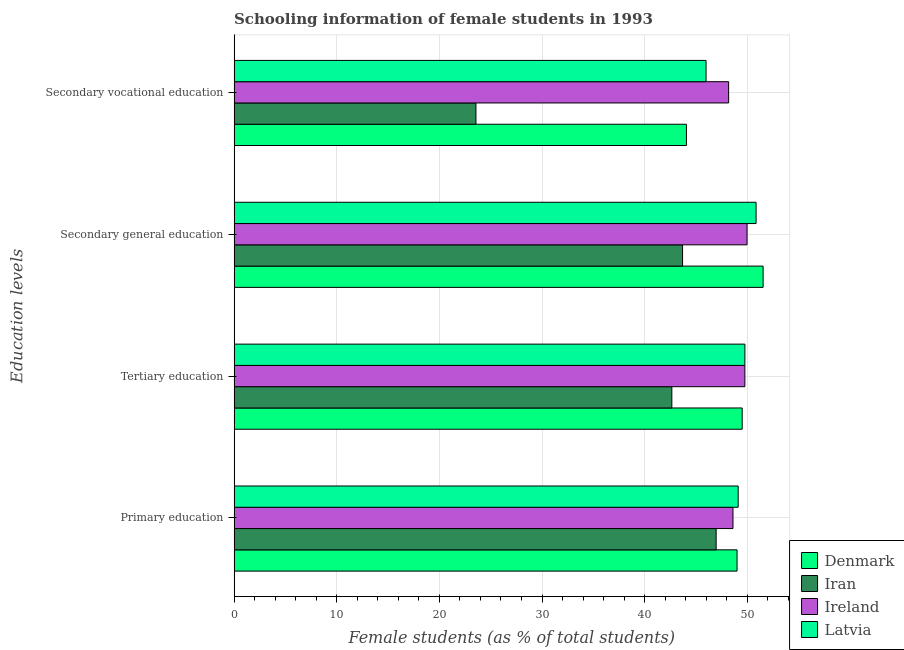How many bars are there on the 2nd tick from the top?
Offer a terse response. 4. How many bars are there on the 1st tick from the bottom?
Provide a succinct answer. 4. What is the label of the 3rd group of bars from the top?
Your answer should be very brief. Tertiary education. What is the percentage of female students in primary education in Ireland?
Provide a succinct answer. 48.6. Across all countries, what is the maximum percentage of female students in primary education?
Your answer should be compact. 49.11. Across all countries, what is the minimum percentage of female students in tertiary education?
Offer a very short reply. 42.65. In which country was the percentage of female students in secondary vocational education maximum?
Make the answer very short. Ireland. In which country was the percentage of female students in secondary vocational education minimum?
Offer a very short reply. Iran. What is the total percentage of female students in tertiary education in the graph?
Provide a succinct answer. 191.67. What is the difference between the percentage of female students in secondary education in Latvia and that in Denmark?
Ensure brevity in your answer.  -0.68. What is the difference between the percentage of female students in tertiary education in Latvia and the percentage of female students in primary education in Denmark?
Provide a short and direct response. 0.76. What is the average percentage of female students in secondary education per country?
Make the answer very short. 49.01. What is the difference between the percentage of female students in primary education and percentage of female students in tertiary education in Ireland?
Your answer should be compact. -1.16. In how many countries, is the percentage of female students in tertiary education greater than 40 %?
Make the answer very short. 4. What is the ratio of the percentage of female students in secondary vocational education in Denmark to that in Ireland?
Keep it short and to the point. 0.91. Is the percentage of female students in tertiary education in Ireland less than that in Latvia?
Your answer should be compact. Yes. What is the difference between the highest and the second highest percentage of female students in secondary vocational education?
Ensure brevity in your answer.  2.2. What is the difference between the highest and the lowest percentage of female students in primary education?
Make the answer very short. 2.15. Is the sum of the percentage of female students in tertiary education in Latvia and Denmark greater than the maximum percentage of female students in secondary education across all countries?
Provide a succinct answer. Yes. Is it the case that in every country, the sum of the percentage of female students in primary education and percentage of female students in tertiary education is greater than the sum of percentage of female students in secondary vocational education and percentage of female students in secondary education?
Offer a terse response. No. What does the 1st bar from the top in Secondary general education represents?
Give a very brief answer. Latvia. What does the 4th bar from the bottom in Secondary general education represents?
Keep it short and to the point. Latvia. Is it the case that in every country, the sum of the percentage of female students in primary education and percentage of female students in tertiary education is greater than the percentage of female students in secondary education?
Give a very brief answer. Yes. Are all the bars in the graph horizontal?
Your answer should be very brief. Yes. How many countries are there in the graph?
Your response must be concise. 4. Does the graph contain any zero values?
Ensure brevity in your answer.  No. Where does the legend appear in the graph?
Your response must be concise. Bottom right. How many legend labels are there?
Keep it short and to the point. 4. What is the title of the graph?
Your response must be concise. Schooling information of female students in 1993. What is the label or title of the X-axis?
Provide a succinct answer. Female students (as % of total students). What is the label or title of the Y-axis?
Your answer should be very brief. Education levels. What is the Female students (as % of total students) of Denmark in Primary education?
Keep it short and to the point. 49. What is the Female students (as % of total students) in Iran in Primary education?
Offer a terse response. 46.96. What is the Female students (as % of total students) in Ireland in Primary education?
Provide a succinct answer. 48.6. What is the Female students (as % of total students) in Latvia in Primary education?
Offer a very short reply. 49.11. What is the Female students (as % of total students) of Denmark in Tertiary education?
Offer a very short reply. 49.5. What is the Female students (as % of total students) in Iran in Tertiary education?
Give a very brief answer. 42.65. What is the Female students (as % of total students) of Ireland in Tertiary education?
Give a very brief answer. 49.76. What is the Female students (as % of total students) of Latvia in Tertiary education?
Provide a short and direct response. 49.76. What is the Female students (as % of total students) in Denmark in Secondary general education?
Offer a terse response. 51.54. What is the Female students (as % of total students) in Iran in Secondary general education?
Your response must be concise. 43.69. What is the Female students (as % of total students) of Ireland in Secondary general education?
Your answer should be compact. 49.97. What is the Female students (as % of total students) of Latvia in Secondary general education?
Keep it short and to the point. 50.86. What is the Female students (as % of total students) in Denmark in Secondary vocational education?
Offer a terse response. 44.07. What is the Female students (as % of total students) of Iran in Secondary vocational education?
Offer a very short reply. 23.56. What is the Female students (as % of total students) of Ireland in Secondary vocational education?
Give a very brief answer. 48.18. What is the Female students (as % of total students) of Latvia in Secondary vocational education?
Your response must be concise. 45.98. Across all Education levels, what is the maximum Female students (as % of total students) in Denmark?
Your response must be concise. 51.54. Across all Education levels, what is the maximum Female students (as % of total students) in Iran?
Your answer should be very brief. 46.96. Across all Education levels, what is the maximum Female students (as % of total students) in Ireland?
Keep it short and to the point. 49.97. Across all Education levels, what is the maximum Female students (as % of total students) of Latvia?
Your answer should be compact. 50.86. Across all Education levels, what is the minimum Female students (as % of total students) of Denmark?
Ensure brevity in your answer.  44.07. Across all Education levels, what is the minimum Female students (as % of total students) of Iran?
Offer a very short reply. 23.56. Across all Education levels, what is the minimum Female students (as % of total students) in Ireland?
Ensure brevity in your answer.  48.18. Across all Education levels, what is the minimum Female students (as % of total students) in Latvia?
Your response must be concise. 45.98. What is the total Female students (as % of total students) in Denmark in the graph?
Your response must be concise. 194.11. What is the total Female students (as % of total students) in Iran in the graph?
Provide a succinct answer. 156.86. What is the total Female students (as % of total students) in Ireland in the graph?
Ensure brevity in your answer.  196.52. What is the total Female students (as % of total students) of Latvia in the graph?
Provide a succinct answer. 195.71. What is the difference between the Female students (as % of total students) of Denmark in Primary education and that in Tertiary education?
Your answer should be very brief. -0.5. What is the difference between the Female students (as % of total students) of Iran in Primary education and that in Tertiary education?
Offer a terse response. 4.32. What is the difference between the Female students (as % of total students) in Ireland in Primary education and that in Tertiary education?
Offer a very short reply. -1.16. What is the difference between the Female students (as % of total students) in Latvia in Primary education and that in Tertiary education?
Your response must be concise. -0.65. What is the difference between the Female students (as % of total students) in Denmark in Primary education and that in Secondary general education?
Provide a short and direct response. -2.54. What is the difference between the Female students (as % of total students) in Iran in Primary education and that in Secondary general education?
Your answer should be compact. 3.27. What is the difference between the Female students (as % of total students) of Ireland in Primary education and that in Secondary general education?
Your response must be concise. -1.37. What is the difference between the Female students (as % of total students) in Latvia in Primary education and that in Secondary general education?
Provide a short and direct response. -1.75. What is the difference between the Female students (as % of total students) of Denmark in Primary education and that in Secondary vocational education?
Make the answer very short. 4.93. What is the difference between the Female students (as % of total students) of Iran in Primary education and that in Secondary vocational education?
Offer a terse response. 23.4. What is the difference between the Female students (as % of total students) in Ireland in Primary education and that in Secondary vocational education?
Keep it short and to the point. 0.43. What is the difference between the Female students (as % of total students) of Latvia in Primary education and that in Secondary vocational education?
Ensure brevity in your answer.  3.13. What is the difference between the Female students (as % of total students) of Denmark in Tertiary education and that in Secondary general education?
Make the answer very short. -2.04. What is the difference between the Female students (as % of total students) of Iran in Tertiary education and that in Secondary general education?
Ensure brevity in your answer.  -1.04. What is the difference between the Female students (as % of total students) of Ireland in Tertiary education and that in Secondary general education?
Keep it short and to the point. -0.21. What is the difference between the Female students (as % of total students) of Latvia in Tertiary education and that in Secondary general education?
Provide a short and direct response. -1.09. What is the difference between the Female students (as % of total students) of Denmark in Tertiary education and that in Secondary vocational education?
Offer a very short reply. 5.43. What is the difference between the Female students (as % of total students) in Iran in Tertiary education and that in Secondary vocational education?
Ensure brevity in your answer.  19.09. What is the difference between the Female students (as % of total students) of Ireland in Tertiary education and that in Secondary vocational education?
Ensure brevity in your answer.  1.58. What is the difference between the Female students (as % of total students) in Latvia in Tertiary education and that in Secondary vocational education?
Give a very brief answer. 3.78. What is the difference between the Female students (as % of total students) in Denmark in Secondary general education and that in Secondary vocational education?
Offer a terse response. 7.47. What is the difference between the Female students (as % of total students) in Iran in Secondary general education and that in Secondary vocational education?
Make the answer very short. 20.13. What is the difference between the Female students (as % of total students) of Ireland in Secondary general education and that in Secondary vocational education?
Keep it short and to the point. 1.79. What is the difference between the Female students (as % of total students) in Latvia in Secondary general education and that in Secondary vocational education?
Make the answer very short. 4.87. What is the difference between the Female students (as % of total students) of Denmark in Primary education and the Female students (as % of total students) of Iran in Tertiary education?
Make the answer very short. 6.35. What is the difference between the Female students (as % of total students) of Denmark in Primary education and the Female students (as % of total students) of Ireland in Tertiary education?
Your answer should be very brief. -0.76. What is the difference between the Female students (as % of total students) in Denmark in Primary education and the Female students (as % of total students) in Latvia in Tertiary education?
Make the answer very short. -0.76. What is the difference between the Female students (as % of total students) in Iran in Primary education and the Female students (as % of total students) in Ireland in Tertiary education?
Your answer should be very brief. -2.8. What is the difference between the Female students (as % of total students) of Iran in Primary education and the Female students (as % of total students) of Latvia in Tertiary education?
Provide a succinct answer. -2.8. What is the difference between the Female students (as % of total students) in Ireland in Primary education and the Female students (as % of total students) in Latvia in Tertiary education?
Give a very brief answer. -1.16. What is the difference between the Female students (as % of total students) of Denmark in Primary education and the Female students (as % of total students) of Iran in Secondary general education?
Provide a succinct answer. 5.31. What is the difference between the Female students (as % of total students) of Denmark in Primary education and the Female students (as % of total students) of Ireland in Secondary general education?
Offer a terse response. -0.97. What is the difference between the Female students (as % of total students) in Denmark in Primary education and the Female students (as % of total students) in Latvia in Secondary general education?
Offer a very short reply. -1.85. What is the difference between the Female students (as % of total students) of Iran in Primary education and the Female students (as % of total students) of Ireland in Secondary general education?
Your answer should be compact. -3.01. What is the difference between the Female students (as % of total students) in Iran in Primary education and the Female students (as % of total students) in Latvia in Secondary general education?
Provide a short and direct response. -3.89. What is the difference between the Female students (as % of total students) of Ireland in Primary education and the Female students (as % of total students) of Latvia in Secondary general education?
Give a very brief answer. -2.25. What is the difference between the Female students (as % of total students) of Denmark in Primary education and the Female students (as % of total students) of Iran in Secondary vocational education?
Your response must be concise. 25.44. What is the difference between the Female students (as % of total students) in Denmark in Primary education and the Female students (as % of total students) in Ireland in Secondary vocational education?
Offer a terse response. 0.82. What is the difference between the Female students (as % of total students) of Denmark in Primary education and the Female students (as % of total students) of Latvia in Secondary vocational education?
Ensure brevity in your answer.  3.02. What is the difference between the Female students (as % of total students) of Iran in Primary education and the Female students (as % of total students) of Ireland in Secondary vocational education?
Provide a succinct answer. -1.22. What is the difference between the Female students (as % of total students) of Iran in Primary education and the Female students (as % of total students) of Latvia in Secondary vocational education?
Ensure brevity in your answer.  0.98. What is the difference between the Female students (as % of total students) of Ireland in Primary education and the Female students (as % of total students) of Latvia in Secondary vocational education?
Your answer should be compact. 2.62. What is the difference between the Female students (as % of total students) of Denmark in Tertiary education and the Female students (as % of total students) of Iran in Secondary general education?
Make the answer very short. 5.81. What is the difference between the Female students (as % of total students) of Denmark in Tertiary education and the Female students (as % of total students) of Ireland in Secondary general education?
Your answer should be compact. -0.47. What is the difference between the Female students (as % of total students) of Denmark in Tertiary education and the Female students (as % of total students) of Latvia in Secondary general education?
Provide a short and direct response. -1.36. What is the difference between the Female students (as % of total students) of Iran in Tertiary education and the Female students (as % of total students) of Ireland in Secondary general education?
Your answer should be very brief. -7.33. What is the difference between the Female students (as % of total students) in Iran in Tertiary education and the Female students (as % of total students) in Latvia in Secondary general education?
Your answer should be very brief. -8.21. What is the difference between the Female students (as % of total students) in Ireland in Tertiary education and the Female students (as % of total students) in Latvia in Secondary general education?
Your response must be concise. -1.09. What is the difference between the Female students (as % of total students) of Denmark in Tertiary education and the Female students (as % of total students) of Iran in Secondary vocational education?
Keep it short and to the point. 25.94. What is the difference between the Female students (as % of total students) of Denmark in Tertiary education and the Female students (as % of total students) of Ireland in Secondary vocational education?
Keep it short and to the point. 1.32. What is the difference between the Female students (as % of total students) of Denmark in Tertiary education and the Female students (as % of total students) of Latvia in Secondary vocational education?
Your response must be concise. 3.52. What is the difference between the Female students (as % of total students) in Iran in Tertiary education and the Female students (as % of total students) in Ireland in Secondary vocational education?
Provide a short and direct response. -5.53. What is the difference between the Female students (as % of total students) of Iran in Tertiary education and the Female students (as % of total students) of Latvia in Secondary vocational education?
Provide a short and direct response. -3.33. What is the difference between the Female students (as % of total students) in Ireland in Tertiary education and the Female students (as % of total students) in Latvia in Secondary vocational education?
Ensure brevity in your answer.  3.78. What is the difference between the Female students (as % of total students) of Denmark in Secondary general education and the Female students (as % of total students) of Iran in Secondary vocational education?
Your answer should be very brief. 27.98. What is the difference between the Female students (as % of total students) in Denmark in Secondary general education and the Female students (as % of total students) in Ireland in Secondary vocational education?
Ensure brevity in your answer.  3.36. What is the difference between the Female students (as % of total students) of Denmark in Secondary general education and the Female students (as % of total students) of Latvia in Secondary vocational education?
Your answer should be compact. 5.56. What is the difference between the Female students (as % of total students) of Iran in Secondary general education and the Female students (as % of total students) of Ireland in Secondary vocational education?
Offer a terse response. -4.49. What is the difference between the Female students (as % of total students) in Iran in Secondary general education and the Female students (as % of total students) in Latvia in Secondary vocational education?
Offer a terse response. -2.29. What is the difference between the Female students (as % of total students) of Ireland in Secondary general education and the Female students (as % of total students) of Latvia in Secondary vocational education?
Ensure brevity in your answer.  3.99. What is the average Female students (as % of total students) in Denmark per Education levels?
Give a very brief answer. 48.53. What is the average Female students (as % of total students) in Iran per Education levels?
Provide a succinct answer. 39.22. What is the average Female students (as % of total students) in Ireland per Education levels?
Ensure brevity in your answer.  49.13. What is the average Female students (as % of total students) of Latvia per Education levels?
Ensure brevity in your answer.  48.93. What is the difference between the Female students (as % of total students) in Denmark and Female students (as % of total students) in Iran in Primary education?
Your answer should be very brief. 2.04. What is the difference between the Female students (as % of total students) in Denmark and Female students (as % of total students) in Ireland in Primary education?
Make the answer very short. 0.4. What is the difference between the Female students (as % of total students) in Denmark and Female students (as % of total students) in Latvia in Primary education?
Your answer should be compact. -0.11. What is the difference between the Female students (as % of total students) in Iran and Female students (as % of total students) in Ireland in Primary education?
Offer a terse response. -1.64. What is the difference between the Female students (as % of total students) in Iran and Female students (as % of total students) in Latvia in Primary education?
Your answer should be compact. -2.15. What is the difference between the Female students (as % of total students) in Ireland and Female students (as % of total students) in Latvia in Primary education?
Ensure brevity in your answer.  -0.51. What is the difference between the Female students (as % of total students) of Denmark and Female students (as % of total students) of Iran in Tertiary education?
Your response must be concise. 6.85. What is the difference between the Female students (as % of total students) in Denmark and Female students (as % of total students) in Ireland in Tertiary education?
Offer a very short reply. -0.26. What is the difference between the Female students (as % of total students) in Denmark and Female students (as % of total students) in Latvia in Tertiary education?
Ensure brevity in your answer.  -0.26. What is the difference between the Female students (as % of total students) in Iran and Female students (as % of total students) in Ireland in Tertiary education?
Offer a terse response. -7.12. What is the difference between the Female students (as % of total students) in Iran and Female students (as % of total students) in Latvia in Tertiary education?
Provide a succinct answer. -7.12. What is the difference between the Female students (as % of total students) in Ireland and Female students (as % of total students) in Latvia in Tertiary education?
Make the answer very short. -0. What is the difference between the Female students (as % of total students) in Denmark and Female students (as % of total students) in Iran in Secondary general education?
Your answer should be very brief. 7.85. What is the difference between the Female students (as % of total students) of Denmark and Female students (as % of total students) of Ireland in Secondary general education?
Make the answer very short. 1.57. What is the difference between the Female students (as % of total students) of Denmark and Female students (as % of total students) of Latvia in Secondary general education?
Ensure brevity in your answer.  0.68. What is the difference between the Female students (as % of total students) in Iran and Female students (as % of total students) in Ireland in Secondary general education?
Your response must be concise. -6.28. What is the difference between the Female students (as % of total students) in Iran and Female students (as % of total students) in Latvia in Secondary general education?
Ensure brevity in your answer.  -7.16. What is the difference between the Female students (as % of total students) in Ireland and Female students (as % of total students) in Latvia in Secondary general education?
Offer a very short reply. -0.88. What is the difference between the Female students (as % of total students) in Denmark and Female students (as % of total students) in Iran in Secondary vocational education?
Your response must be concise. 20.51. What is the difference between the Female students (as % of total students) of Denmark and Female students (as % of total students) of Ireland in Secondary vocational education?
Your answer should be compact. -4.11. What is the difference between the Female students (as % of total students) in Denmark and Female students (as % of total students) in Latvia in Secondary vocational education?
Your response must be concise. -1.91. What is the difference between the Female students (as % of total students) in Iran and Female students (as % of total students) in Ireland in Secondary vocational education?
Offer a very short reply. -24.62. What is the difference between the Female students (as % of total students) in Iran and Female students (as % of total students) in Latvia in Secondary vocational education?
Your response must be concise. -22.42. What is the difference between the Female students (as % of total students) of Ireland and Female students (as % of total students) of Latvia in Secondary vocational education?
Ensure brevity in your answer.  2.2. What is the ratio of the Female students (as % of total students) of Denmark in Primary education to that in Tertiary education?
Your answer should be very brief. 0.99. What is the ratio of the Female students (as % of total students) in Iran in Primary education to that in Tertiary education?
Give a very brief answer. 1.1. What is the ratio of the Female students (as % of total students) of Ireland in Primary education to that in Tertiary education?
Provide a succinct answer. 0.98. What is the ratio of the Female students (as % of total students) in Latvia in Primary education to that in Tertiary education?
Your answer should be very brief. 0.99. What is the ratio of the Female students (as % of total students) of Denmark in Primary education to that in Secondary general education?
Make the answer very short. 0.95. What is the ratio of the Female students (as % of total students) of Iran in Primary education to that in Secondary general education?
Provide a short and direct response. 1.07. What is the ratio of the Female students (as % of total students) in Ireland in Primary education to that in Secondary general education?
Your answer should be very brief. 0.97. What is the ratio of the Female students (as % of total students) in Latvia in Primary education to that in Secondary general education?
Make the answer very short. 0.97. What is the ratio of the Female students (as % of total students) of Denmark in Primary education to that in Secondary vocational education?
Your response must be concise. 1.11. What is the ratio of the Female students (as % of total students) in Iran in Primary education to that in Secondary vocational education?
Your answer should be compact. 1.99. What is the ratio of the Female students (as % of total students) of Ireland in Primary education to that in Secondary vocational education?
Provide a short and direct response. 1.01. What is the ratio of the Female students (as % of total students) in Latvia in Primary education to that in Secondary vocational education?
Your answer should be compact. 1.07. What is the ratio of the Female students (as % of total students) in Denmark in Tertiary education to that in Secondary general education?
Provide a succinct answer. 0.96. What is the ratio of the Female students (as % of total students) of Iran in Tertiary education to that in Secondary general education?
Provide a short and direct response. 0.98. What is the ratio of the Female students (as % of total students) in Ireland in Tertiary education to that in Secondary general education?
Offer a very short reply. 1. What is the ratio of the Female students (as % of total students) of Latvia in Tertiary education to that in Secondary general education?
Provide a succinct answer. 0.98. What is the ratio of the Female students (as % of total students) of Denmark in Tertiary education to that in Secondary vocational education?
Offer a terse response. 1.12. What is the ratio of the Female students (as % of total students) in Iran in Tertiary education to that in Secondary vocational education?
Your response must be concise. 1.81. What is the ratio of the Female students (as % of total students) in Ireland in Tertiary education to that in Secondary vocational education?
Make the answer very short. 1.03. What is the ratio of the Female students (as % of total students) in Latvia in Tertiary education to that in Secondary vocational education?
Keep it short and to the point. 1.08. What is the ratio of the Female students (as % of total students) of Denmark in Secondary general education to that in Secondary vocational education?
Ensure brevity in your answer.  1.17. What is the ratio of the Female students (as % of total students) in Iran in Secondary general education to that in Secondary vocational education?
Offer a terse response. 1.85. What is the ratio of the Female students (as % of total students) in Ireland in Secondary general education to that in Secondary vocational education?
Make the answer very short. 1.04. What is the ratio of the Female students (as % of total students) of Latvia in Secondary general education to that in Secondary vocational education?
Give a very brief answer. 1.11. What is the difference between the highest and the second highest Female students (as % of total students) in Denmark?
Offer a terse response. 2.04. What is the difference between the highest and the second highest Female students (as % of total students) of Iran?
Your answer should be very brief. 3.27. What is the difference between the highest and the second highest Female students (as % of total students) in Ireland?
Keep it short and to the point. 0.21. What is the difference between the highest and the second highest Female students (as % of total students) in Latvia?
Provide a succinct answer. 1.09. What is the difference between the highest and the lowest Female students (as % of total students) in Denmark?
Keep it short and to the point. 7.47. What is the difference between the highest and the lowest Female students (as % of total students) in Iran?
Your response must be concise. 23.4. What is the difference between the highest and the lowest Female students (as % of total students) of Ireland?
Your answer should be compact. 1.79. What is the difference between the highest and the lowest Female students (as % of total students) in Latvia?
Offer a very short reply. 4.87. 